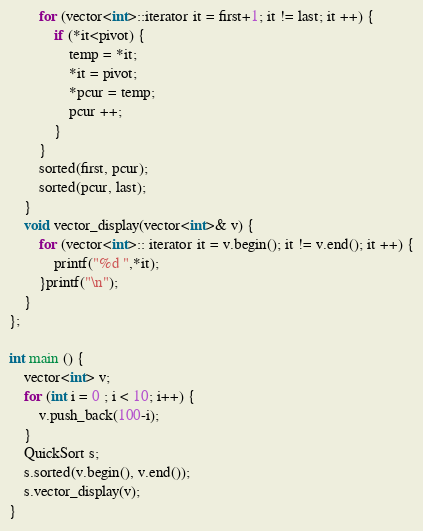Convert code to text. <code><loc_0><loc_0><loc_500><loc_500><_C++_>        for (vector<int>::iterator it = first+1; it != last; it ++) {
            if (*it<pivot) {
                temp = *it;
                *it = pivot;
                *pcur = temp;
                pcur ++;
            }
        }
        sorted(first, pcur);
        sorted(pcur, last);
    }
    void vector_display(vector<int>& v) {
        for (vector<int>:: iterator it = v.begin(); it != v.end(); it ++) {
            printf("%d ",*it);
        }printf("\n");
    }
};

int main () {
    vector<int> v;
    for (int i = 0 ; i < 10; i++) {
        v.push_back(100-i);
    }
    QuickSort s;
    s.sorted(v.begin(), v.end());
    s.vector_display(v);
}</code> 